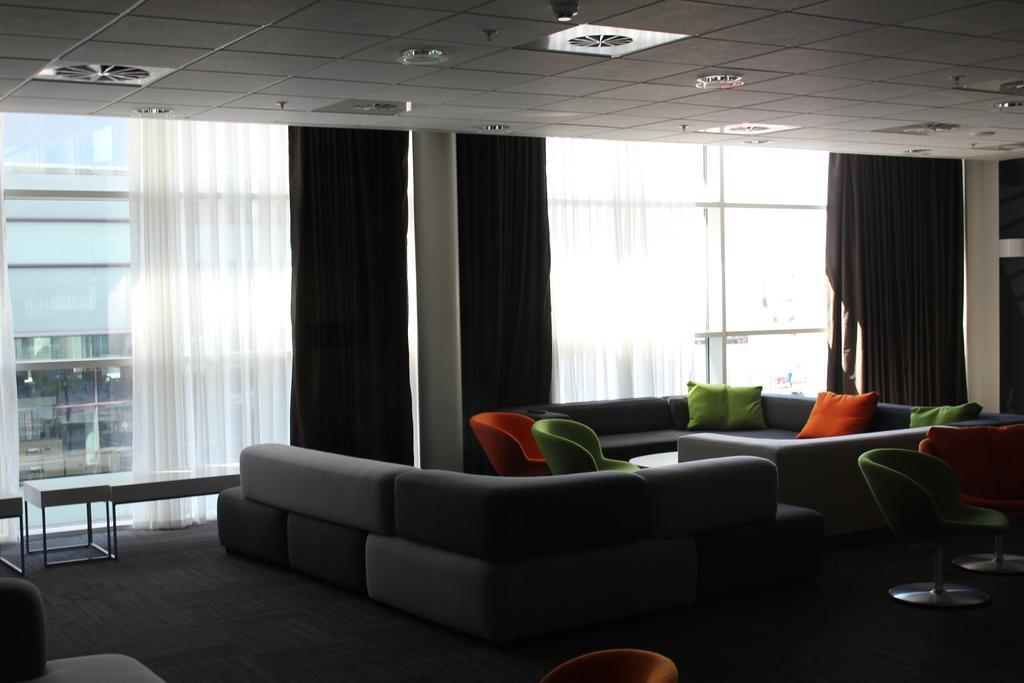Could you give a brief overview of what you see in this image? In the image we can see there is a sofa, there are chairs and the curtains are in white and black colour. 